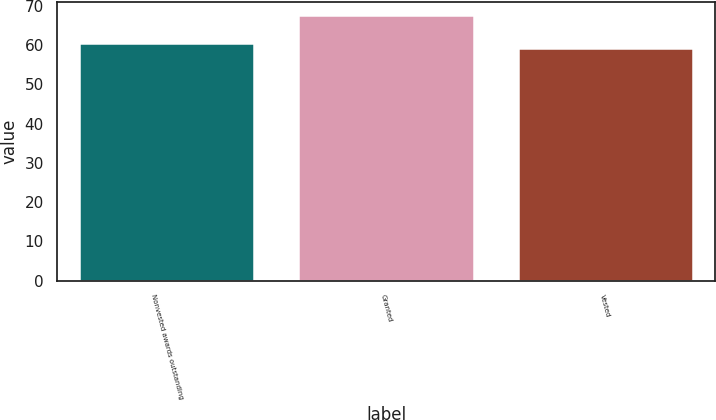Convert chart to OTSL. <chart><loc_0><loc_0><loc_500><loc_500><bar_chart><fcel>Nonvested awards outstanding<fcel>Granted<fcel>Vested<nl><fcel>60.46<fcel>67.48<fcel>59.24<nl></chart> 